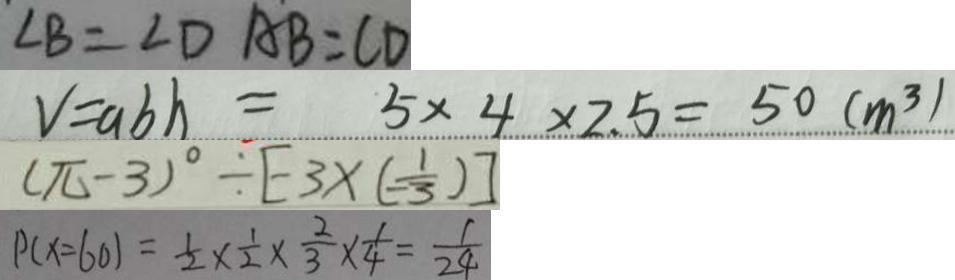<formula> <loc_0><loc_0><loc_500><loc_500>\angle B = \angle D A B = C D 
 V = a b h = 5 \times 4 \times 2 . 5 = 5 0 ( m ^ { 3 } ) 
 ( \pi - 3 ) ^ { \circ } \div [ - 3 \times ( - \frac { 1 } { 3 } ) ] 
 P ( x = 6 0 ) = \frac { 1 } { 2 } \times \frac { 1 } { 2 } \times \frac { 2 } { 3 } \times \frac { 1 } { 4 } = \frac { 1 } { 2 4 }</formula> 